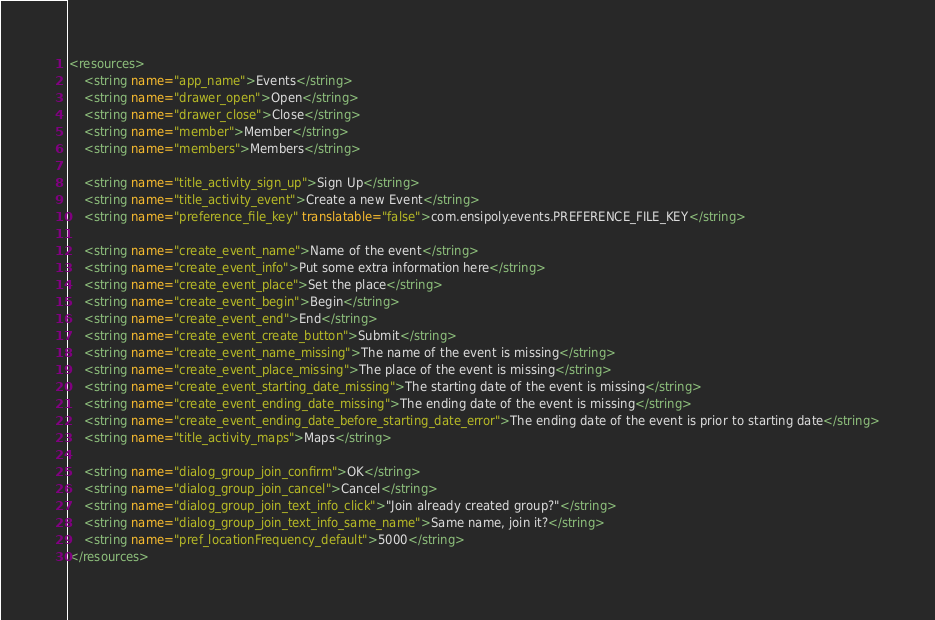<code> <loc_0><loc_0><loc_500><loc_500><_XML_><resources>
    <string name="app_name">Events</string>
    <string name="drawer_open">Open</string>
    <string name="drawer_close">Close</string>
    <string name="member">Member</string>
    <string name="members">Members</string>

    <string name="title_activity_sign_up">Sign Up</string>
    <string name="title_activity_event">Create a new Event</string>
    <string name="preference_file_key" translatable="false">com.ensipoly.events.PREFERENCE_FILE_KEY</string>

    <string name="create_event_name">Name of the event</string>
    <string name="create_event_info">Put some extra information here</string>
    <string name="create_event_place">Set the place</string>
    <string name="create_event_begin">Begin</string>
    <string name="create_event_end">End</string>
    <string name="create_event_create_button">Submit</string>
    <string name="create_event_name_missing">The name of the event is missing</string>
    <string name="create_event_place_missing">The place of the event is missing</string>
    <string name="create_event_starting_date_missing">The starting date of the event is missing</string>
    <string name="create_event_ending_date_missing">The ending date of the event is missing</string>
    <string name="create_event_ending_date_before_starting_date_error">The ending date of the event is prior to starting date</string>
    <string name="title_activity_maps">Maps</string>

    <string name="dialog_group_join_confirm">OK</string>
    <string name="dialog_group_join_cancel">Cancel</string>
    <string name="dialog_group_join_text_info_click">"Join already created group?"</string>
    <string name="dialog_group_join_text_info_same_name">Same name, join it?</string>
    <string name="pref_locationFrequency_default">5000</string>
</resources>
</code> 